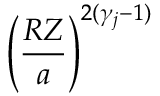<formula> <loc_0><loc_0><loc_500><loc_500>\left ( \frac { R Z } { a } \right ) ^ { 2 ( \gamma _ { j } - 1 ) }</formula> 